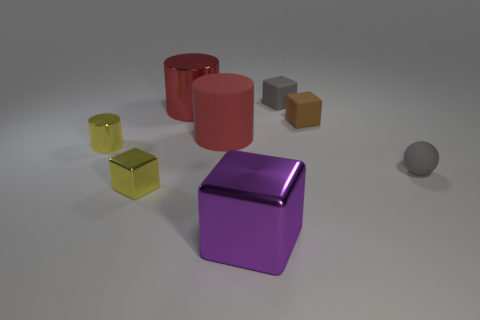Subtract 1 cubes. How many cubes are left? 3 Add 1 tiny yellow matte balls. How many objects exist? 9 Subtract all cylinders. How many objects are left? 5 Subtract 1 brown cubes. How many objects are left? 7 Subtract all metal cubes. Subtract all matte cylinders. How many objects are left? 5 Add 4 gray matte balls. How many gray matte balls are left? 5 Add 6 big red metallic objects. How many big red metallic objects exist? 7 